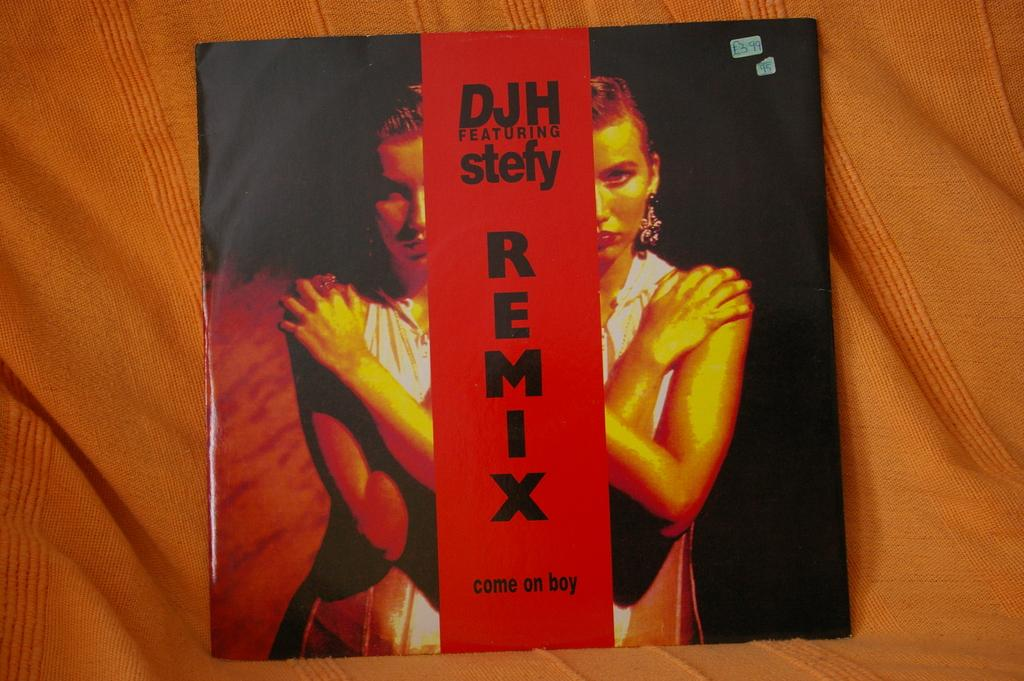<image>
Provide a brief description of the given image. Picture of a DVD cover with the word REMIX on it. 